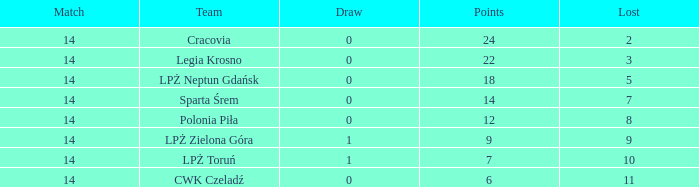What is the highest loss with points less than 7? 11.0. I'm looking to parse the entire table for insights. Could you assist me with that? {'header': ['Match', 'Team', 'Draw', 'Points', 'Lost'], 'rows': [['14', 'Cracovia', '0', '24', '2'], ['14', 'Legia Krosno', '0', '22', '3'], ['14', 'LPŻ Neptun Gdańsk', '0', '18', '5'], ['14', 'Sparta Śrem', '0', '14', '7'], ['14', 'Polonia Piła', '0', '12', '8'], ['14', 'LPŻ Zielona Góra', '1', '9', '9'], ['14', 'LPŻ Toruń', '1', '7', '10'], ['14', 'CWK Czeladź', '0', '6', '11']]} 